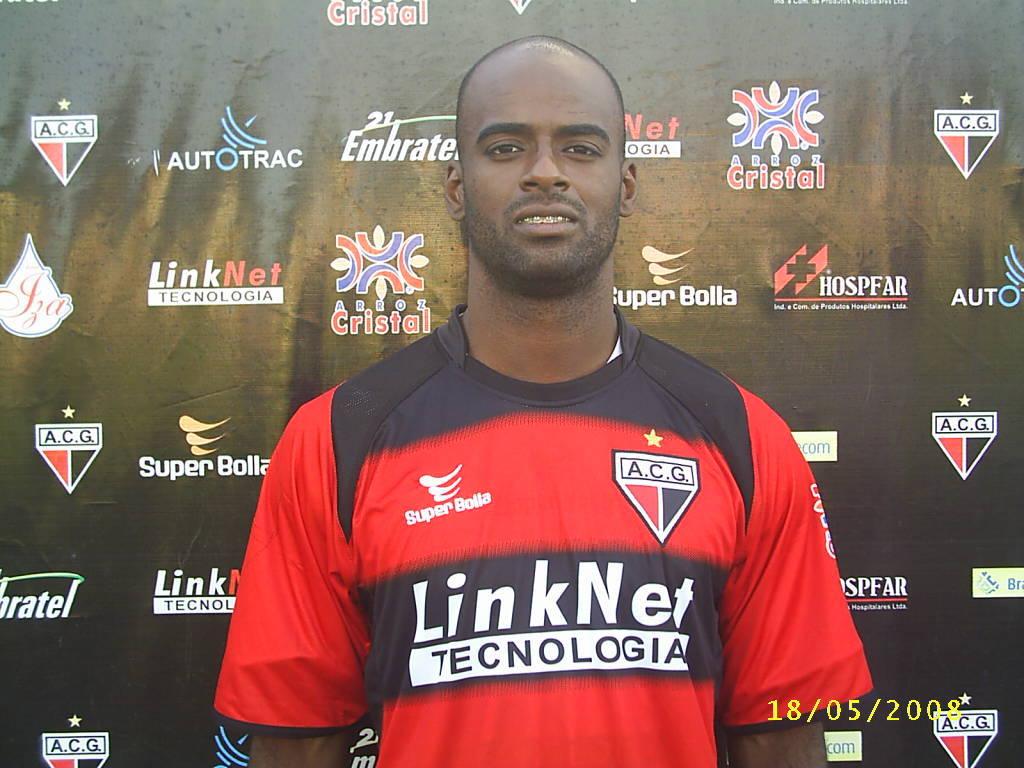Who is a sponsor on the back panel?
Your answer should be very brief. Autotrac. 